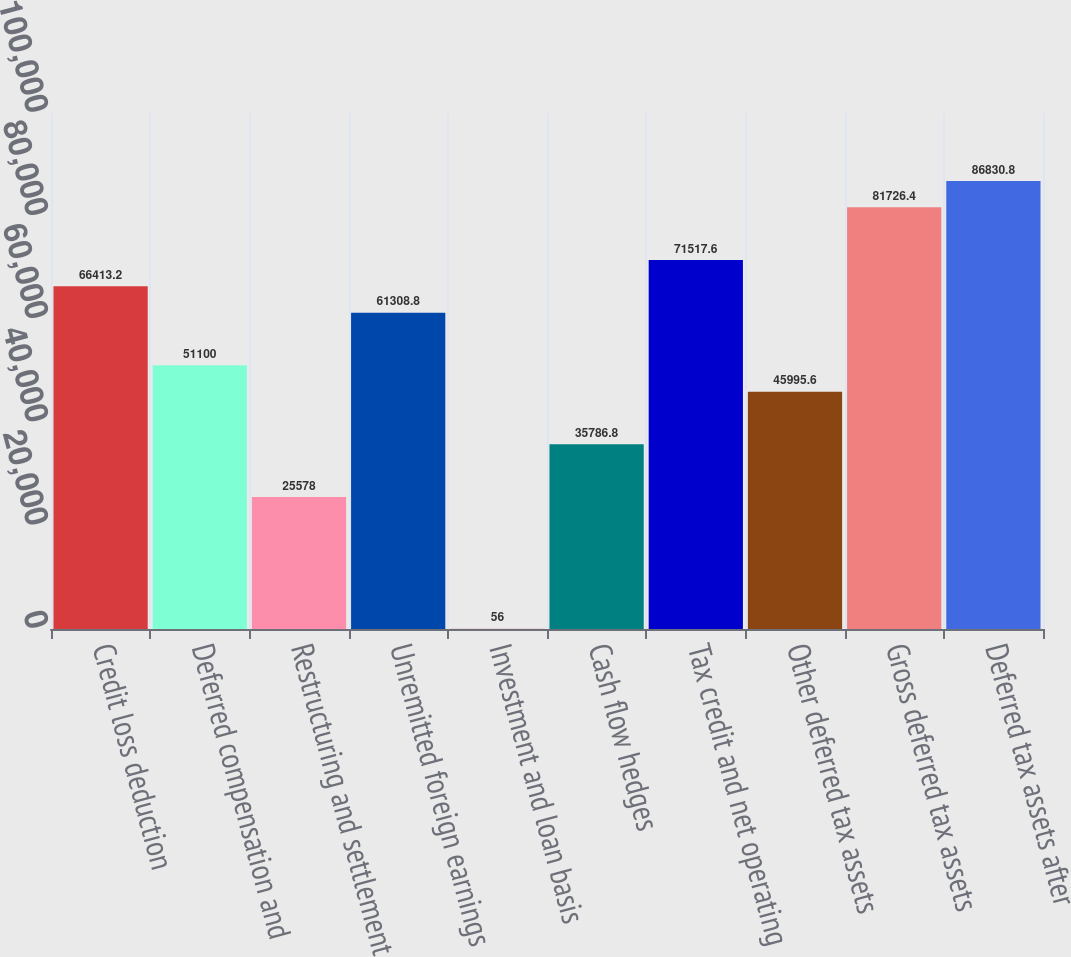Convert chart to OTSL. <chart><loc_0><loc_0><loc_500><loc_500><bar_chart><fcel>Credit loss deduction<fcel>Deferred compensation and<fcel>Restructuring and settlement<fcel>Unremitted foreign earnings<fcel>Investment and loan basis<fcel>Cash flow hedges<fcel>Tax credit and net operating<fcel>Other deferred tax assets<fcel>Gross deferred tax assets<fcel>Deferred tax assets after<nl><fcel>66413.2<fcel>51100<fcel>25578<fcel>61308.8<fcel>56<fcel>35786.8<fcel>71517.6<fcel>45995.6<fcel>81726.4<fcel>86830.8<nl></chart> 